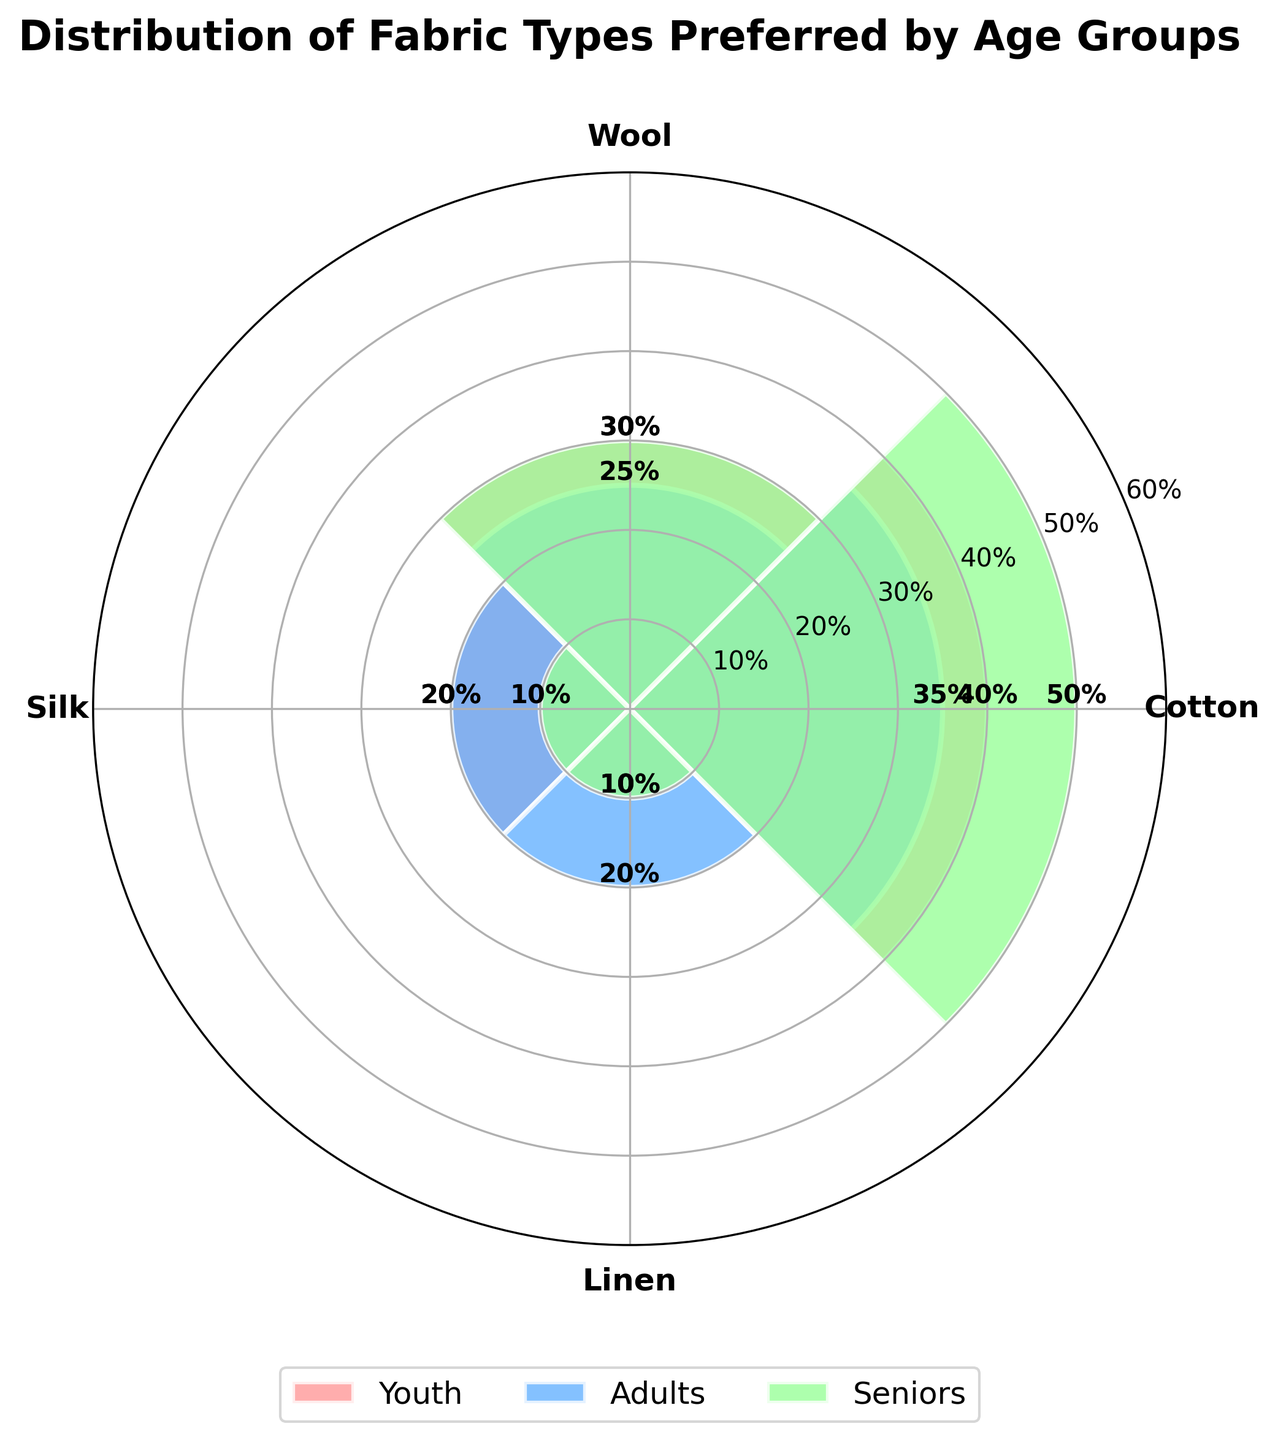Which age group has the highest preference for cotton? From the figure, the percentage labels show that Seniors prefer cotton the most, with a preference percentage of 50.
Answer: Seniors What is the title of the figure? The title is usually located at the top of the chart in bold, larger font. It reads 'Distribution of Fabric Types Preferred by Age Groups'.
Answer: Distribution of Fabric Types Preferred by Age Groups Which fabric type is least preferred by Youth? Analyzing the different segments for the Youth group, the smallest segment is for Satin with a preference percentage of 10.
Answer: Satin How many fabric types have exactly 20% preference among Adults? In the Adults group's bars, both Silk and Linen have preference percentages of 20%, making it two fabric types.
Answer: 2 Which fabric type is preferred by all three age groups? Reviewing the segments for each age group, Cotton appears in all three: Youth, Adults, and Seniors.
Answer: Cotton What is the combined preference percentage for Denim and Satin among Youth? For Youth, Denim has a preference percentage of 20 and Satin has 10. Adding these, the combined percentage is 20 + 10 = 30.
Answer: 30 Which age group prefers Polyester more, Youth or Adults? Comparing the segments for Polyester between Youth (30%) and Adults (25%) shows that Youth prefers it more.
Answer: Youth What is the total preference percentage for Wool and Silk among Seniors? For Seniors, Wool is preferred at 30% and Silk at 10%. Adding these together, we get 30 + 10 = 40.
Answer: 40 How does the preference for Cotton change from Youth to Adults to Seniors? The figure shows that Youth have a 40% preference for Cotton, Adults have 35%, and Seniors have 50%, showing a decrease from Youth to Adults and then an increase in Seniors.
Answer: Decreases then increases Which fabric type has the same preference percentage among two or more different age groups? Both Silk and Linen have the same preference percentage of 20% among the Adults, and Linen has the same percentage of 10% among Adults and Seniors.
Answer: Linen 